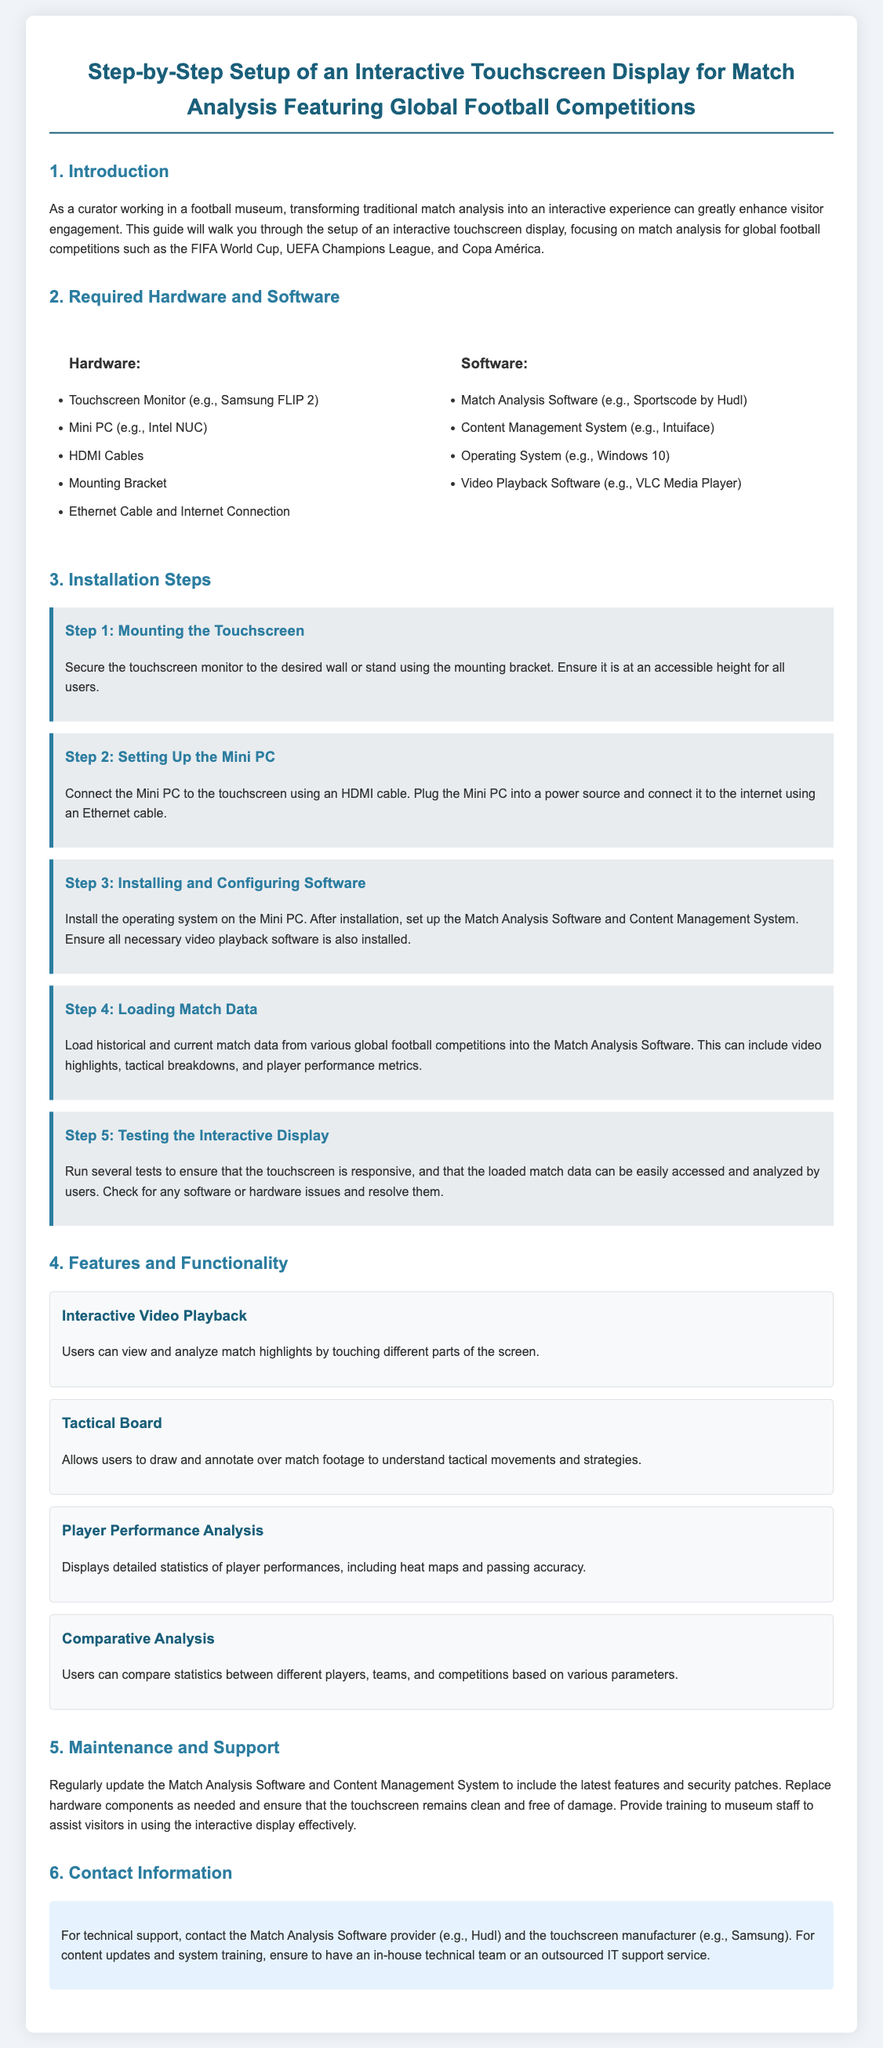What is the title of the document? The title of the document is mentioned at the top of the assembly instructions.
Answer: Step-by-Step Setup of an Interactive Touchscreen Display for Match Analysis Featuring Global Football Competitions What is one type of software required for setup? The document lists required software under the "Software" section, including examples such as the Match Analysis Software.
Answer: Match Analysis Software How many steps are there in the installation process? The document outlines specific steps in the installation process under the "Installation Steps" section.
Answer: Five What is the first step for installation? The first installation step is highlighted as "Step 1" in the document, outlining what needs to be done initially.
Answer: Mounting the Touchscreen What does the Tactical Board feature allow users to do? The document describes the features and functionality of the interactive display, specifically mentioning the purpose of the Tactical Board.
Answer: Draw and annotate Why is it important to regularly update the software? The document emphasizes maintenance and support, highlighting the importance of updates for security and features.
Answer: Security patches Who should be contacted for technical support? The document provides information on who to reach out to for technical assistance in the "Contact Information" section.
Answer: Match Analysis Software provider What device is recommended for the touchscreen monitor? The document includes specific hardware recommendations and provides an example of a suitable touchscreen monitor.
Answer: Samsung FLIP 2 